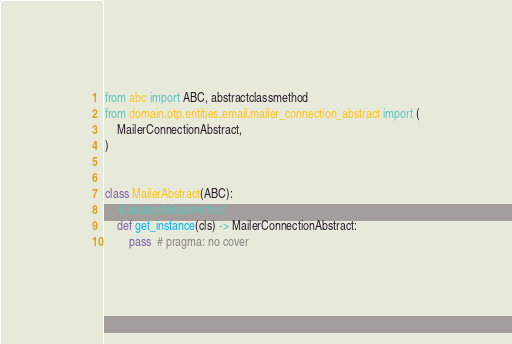Convert code to text. <code><loc_0><loc_0><loc_500><loc_500><_Python_>from abc import ABC, abstractclassmethod
from domain.otp.entities.email.mailer_connection_abstract import (
    MailerConnectionAbstract,
)


class MailerAbstract(ABC):
    @abstractclassmethod
    def get_instance(cls) -> MailerConnectionAbstract:
        pass  # pragma: no cover
</code> 